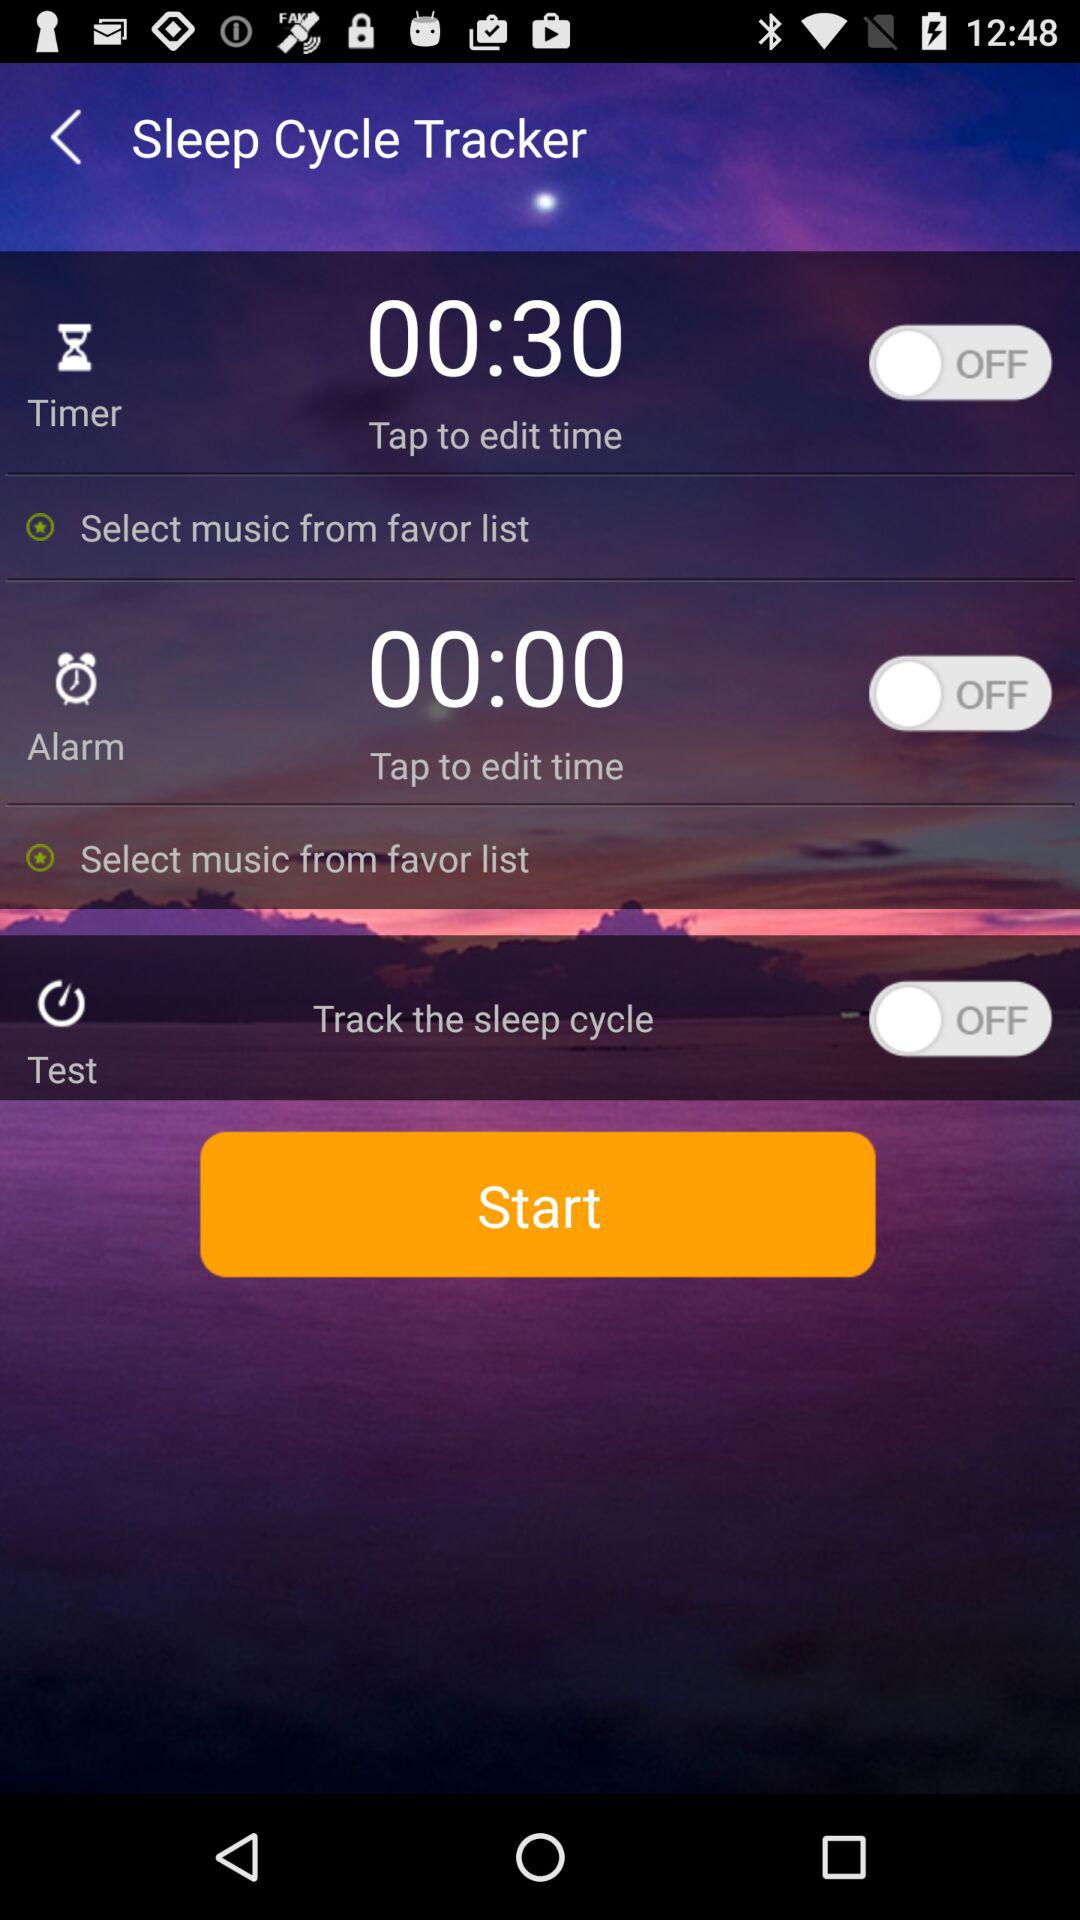What is the value of the alarm? The value is 00:00. 